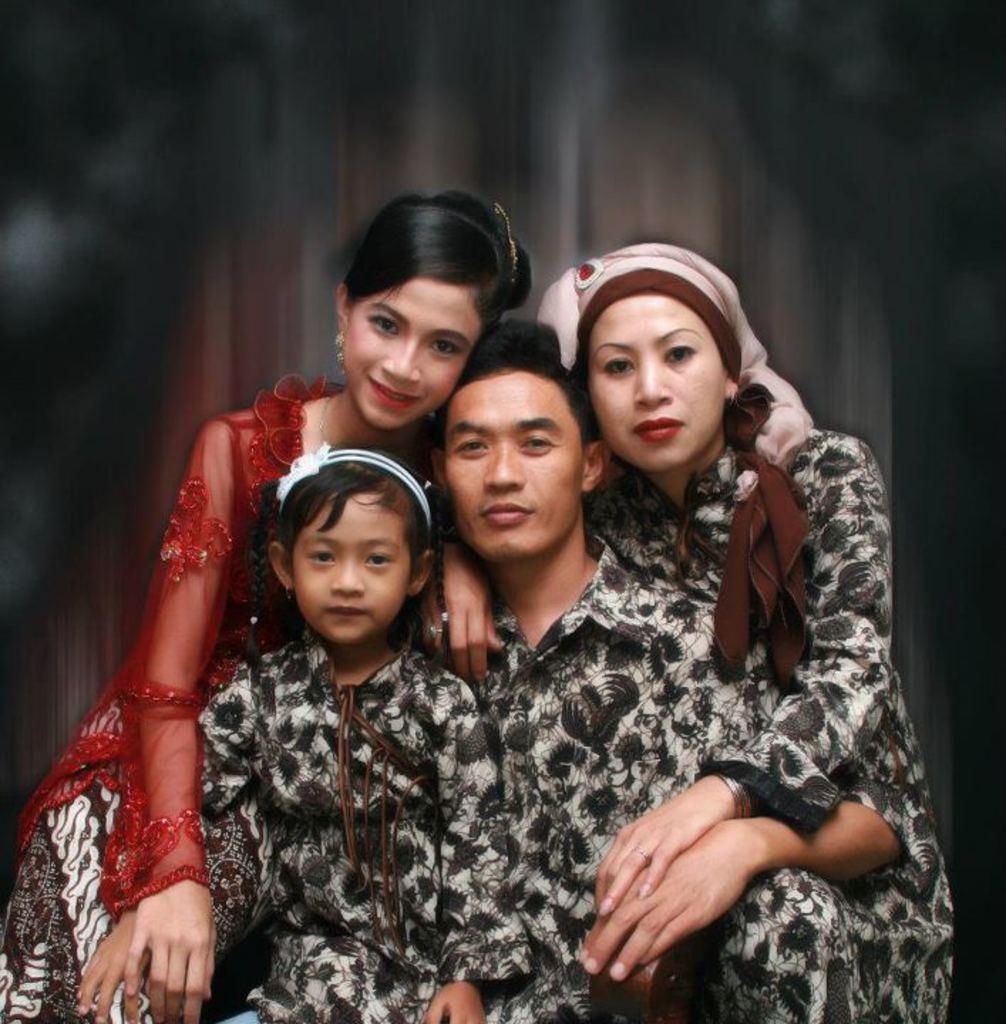Can you describe this image briefly? In this image we can see persons sitting. 